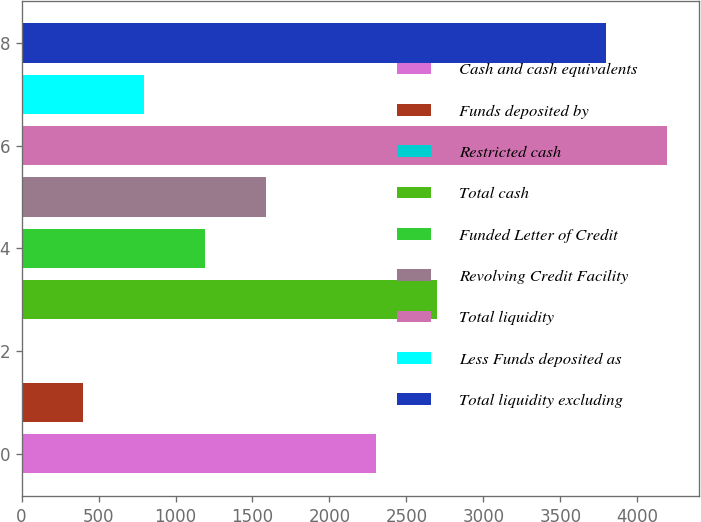<chart> <loc_0><loc_0><loc_500><loc_500><bar_chart><fcel>Cash and cash equivalents<fcel>Funds deposited by<fcel>Restricted cash<fcel>Total cash<fcel>Funded Letter of Credit<fcel>Revolving Credit Facility<fcel>Total liquidity<fcel>Less Funds deposited as<fcel>Total liquidity excluding<nl><fcel>2304<fcel>398.9<fcel>2<fcel>2700.9<fcel>1192.7<fcel>1589.6<fcel>4190.9<fcel>795.8<fcel>3794<nl></chart> 